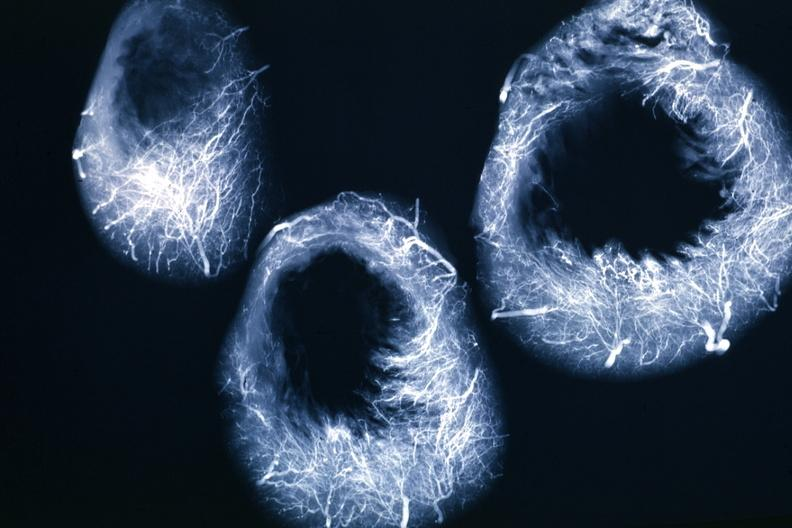s angiogram present?
Answer the question using a single word or phrase. Yes 